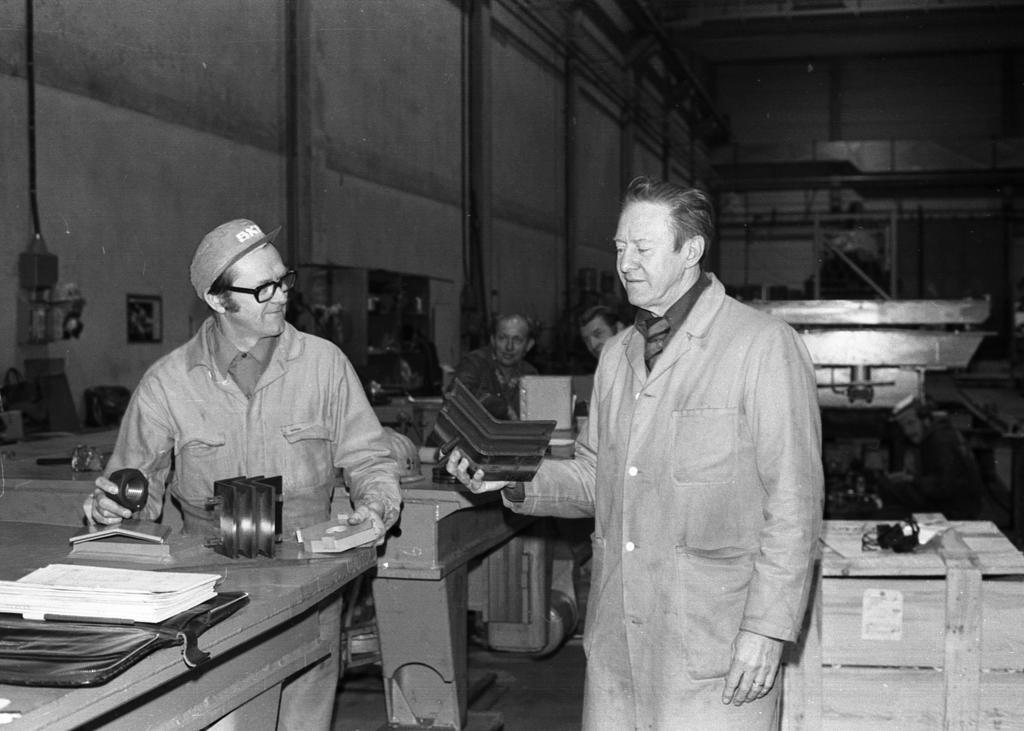Describe this image in one or two sentences. In this image in the foreground there are two persons who are standing and one person is holding something, in the background there are some people who are sitting. And on the right side and left side there are some machines, and at the bottom there are some papers. In the background there is a wall and some poles. 